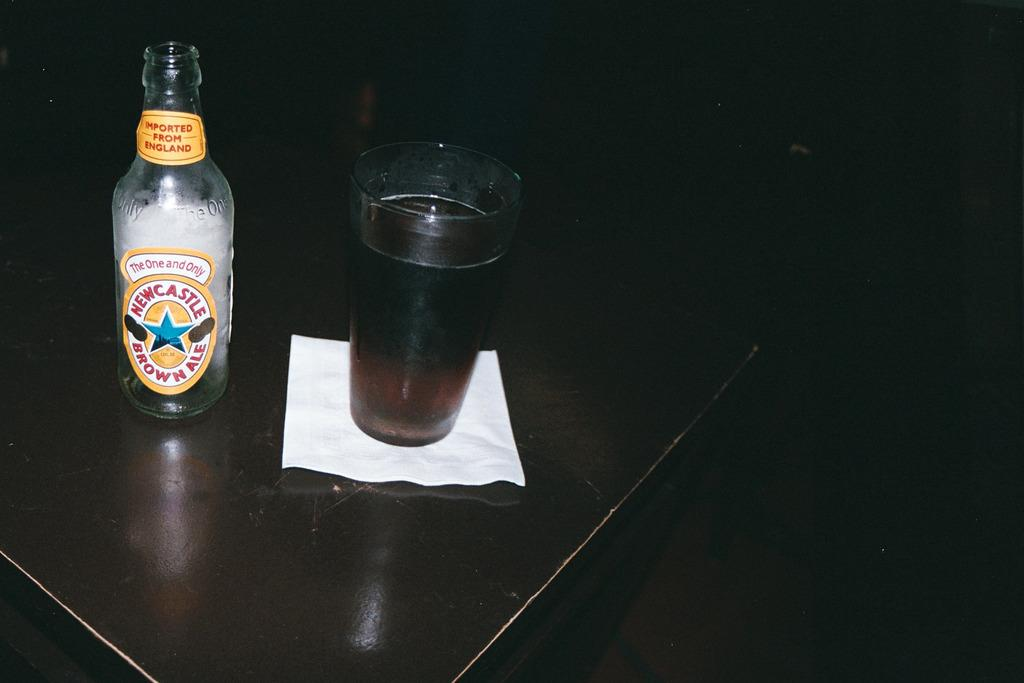What is one of the objects visible in the image? There is a bottle in the image. What else can be seen in the image? There is a glass of drink in the image. How is the glass of drink positioned in the image? The glass of drink is on a tissue paper. Where is the tissue paper located? The tissue paper is on a table. What type of hook is attached to the glass of drink in the image? There is no hook attached to the glass of drink in the image. Can you describe the sink that is visible in the image? There is no sink present in the image. 